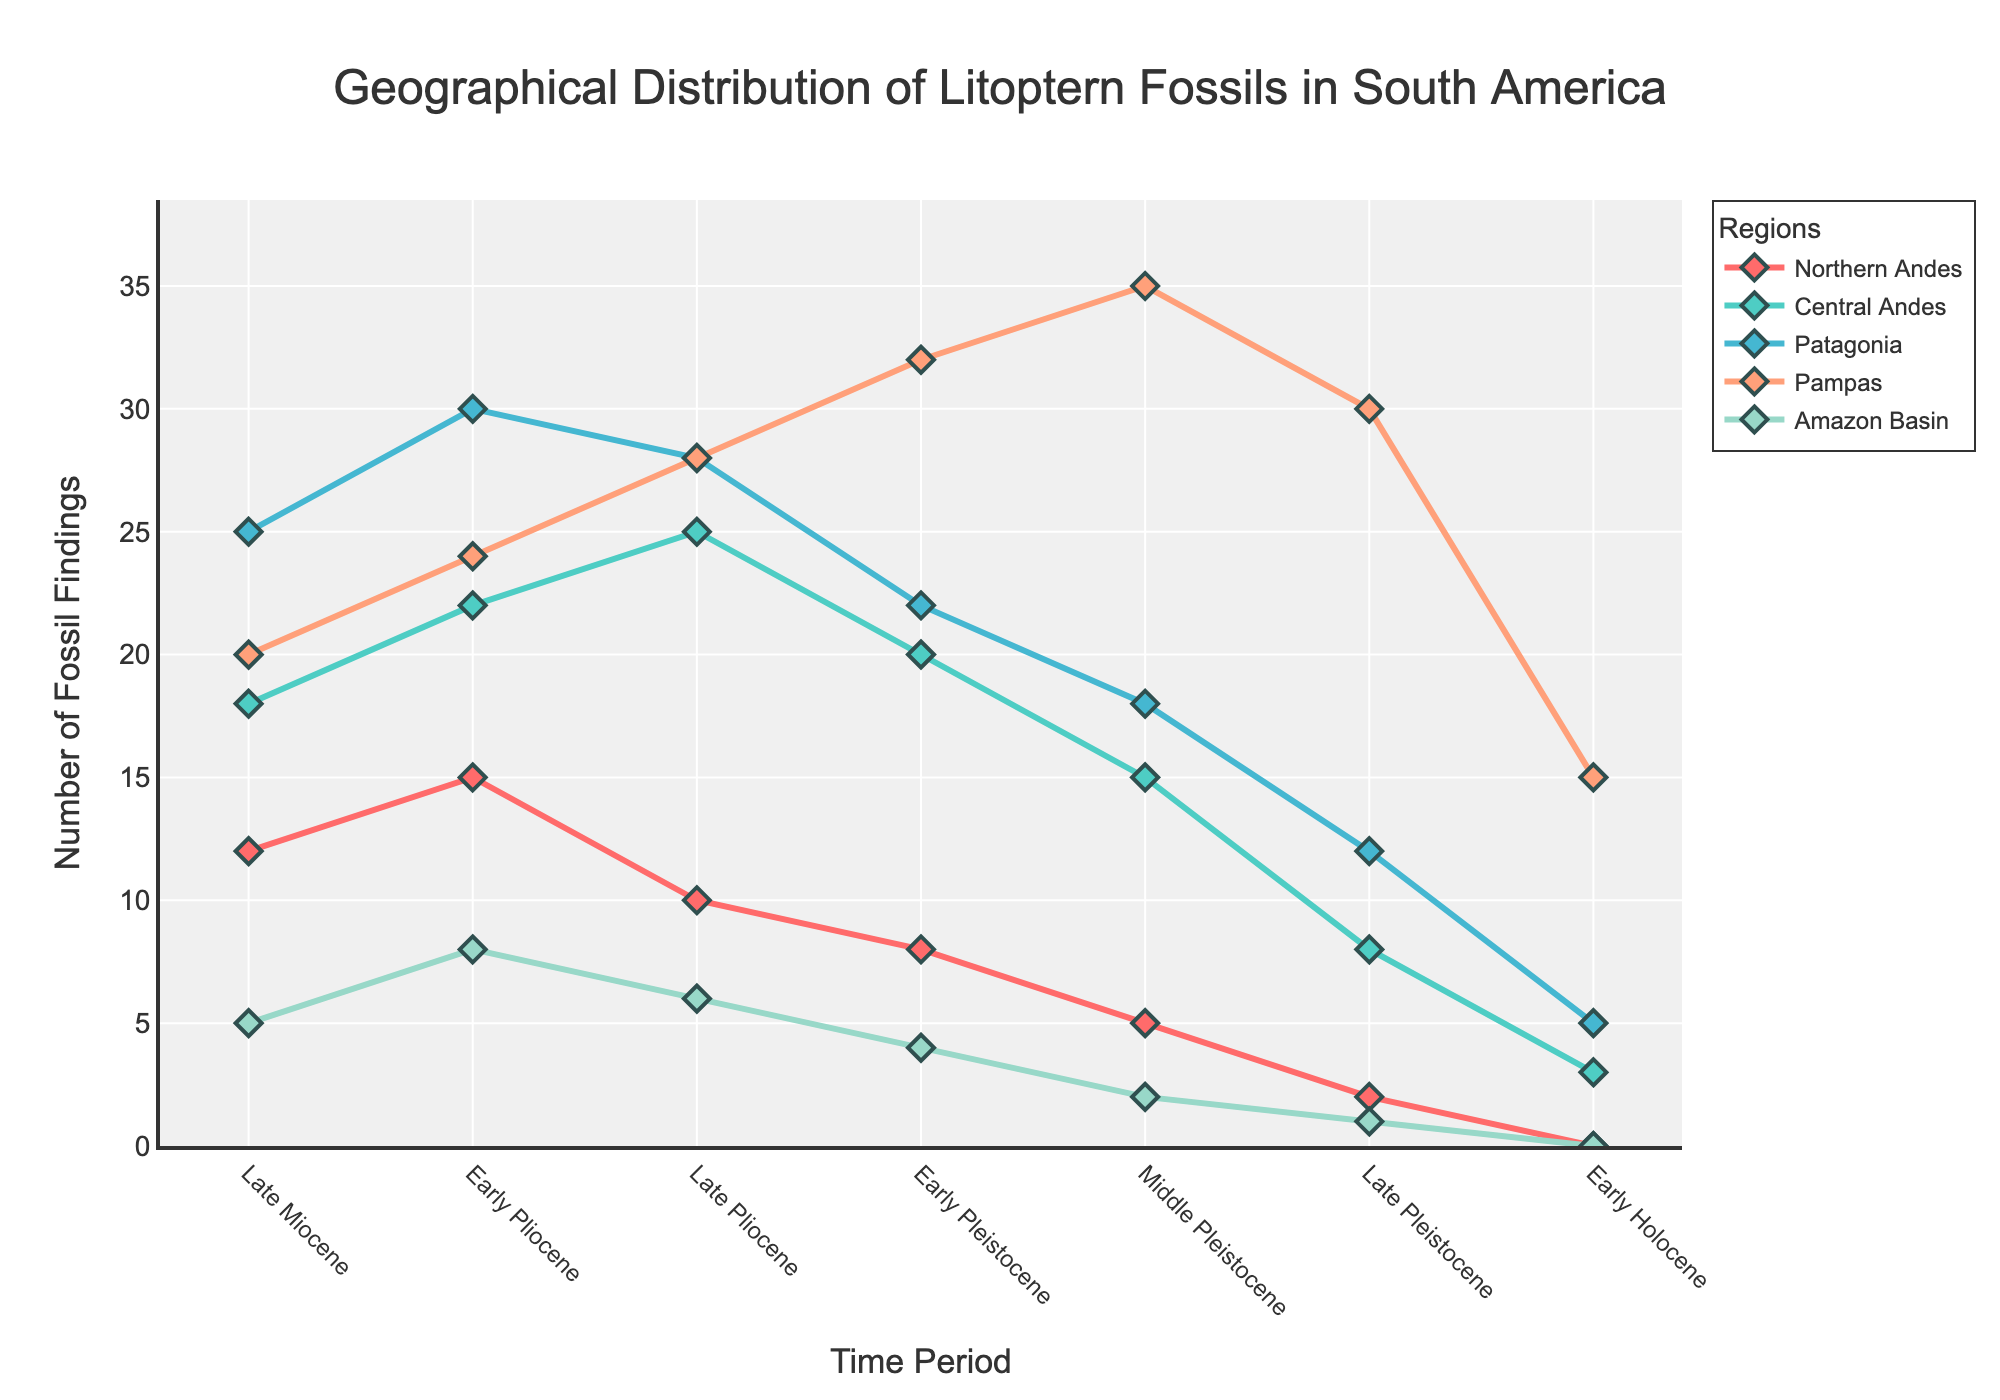What is the trend in the number of Litoptern fossils found in Patagonia from the Late Miocene to the Early Holocene? Compare the fossil findings for each time period in Patagonia. Observing the visual trend, the number of fossils decreases consistently from 25 in the Late Miocene to 5 in the Early Holocene.
Answer: Decreasing trend Which region shows the highest number of fossil findings in the Late Pleistocene? Look at the figure for the number of findings in each region specifically during the Late Pleistocene. Pampas has the highest value with 30 findings.
Answer: Pampas How do the findings in the Pampas region change over time? Observe the curve corresponding to Pampas. Initially, the number of findings increases over time until the Early Pleistocene and then decreases more sharply towards the Early Holocene.
Answer: Increases, then decreases Which regions have no findings recorded in the Early Holocene? Identify which regions' lines touch the x-axis at the Early Holocene period. Both Northern Andes and Amazon Basin have their line at zero in that time period.
Answer: Northern Andes, Amazon Basin Is there any time period where all regions show fossil findings? Check each time period to see if all regions have non-zero values. From the Late Miocene to the Late Pleistocene, all regions have fossil findings.
Answer: Until Late Pleistocene By how much do the fossil findings in the Northern Andes decrease from the Late Miocene to the Early Holocene? Subtract the number of findings in the Early Holocene from those in the Late Miocene: 12 - 0 = 12.
Answer: 12 During which period do the Central Andes have the highest number of findings, and what is that number? Find the highest point on the curve for the Central Andes region. The late Pliocene has the highest with 25 findings.
Answer: Late Pliocene, 25 Compare the combined number of fossils found in the Northern and Central Andes during the Early Pliocene. Sum the findings in Northern Andes (15) and Central Andes (22) during the Early Pliocene. 15 + 22 = 37.
Answer: 37 What is the rate of change in fossil findings in the Pampas region from the Middle Pleistocene to the Early Holocene? The value in the Middle Pleistocene is 35 and drops to 15 in the Early Holocene. The rate of change is (35 - 15) / (5 - 1) = 5 fossils per time period.
Answer: 5 fossils per time period Which region has the most consistent fossil findings across all time periods? Observe which region's line is the most horizontal and evenly distributed. Patagonia shows the most consistent fossil findings with smaller fluctuations overall.
Answer: Patagonia 